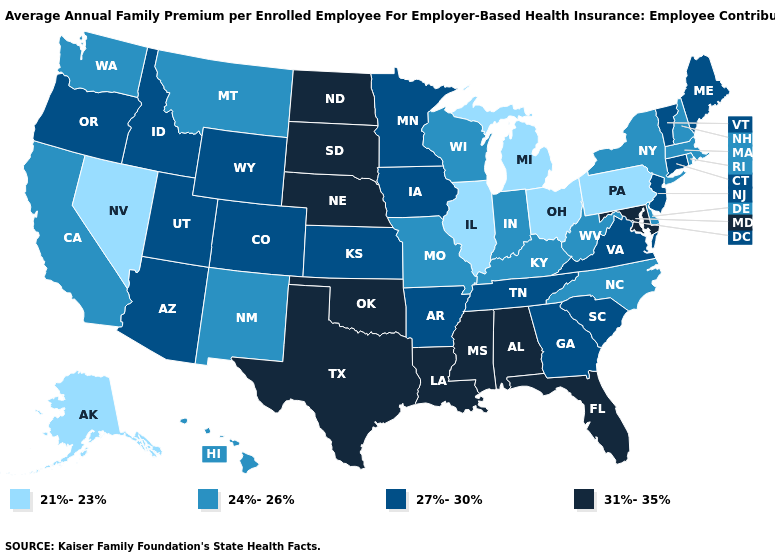Name the states that have a value in the range 27%-30%?
Keep it brief. Arizona, Arkansas, Colorado, Connecticut, Georgia, Idaho, Iowa, Kansas, Maine, Minnesota, New Jersey, Oregon, South Carolina, Tennessee, Utah, Vermont, Virginia, Wyoming. Does the map have missing data?
Write a very short answer. No. Name the states that have a value in the range 21%-23%?
Short answer required. Alaska, Illinois, Michigan, Nevada, Ohio, Pennsylvania. Name the states that have a value in the range 31%-35%?
Write a very short answer. Alabama, Florida, Louisiana, Maryland, Mississippi, Nebraska, North Dakota, Oklahoma, South Dakota, Texas. What is the lowest value in states that border North Carolina?
Short answer required. 27%-30%. What is the value of Oklahoma?
Answer briefly. 31%-35%. Does South Dakota have the highest value in the MidWest?
Answer briefly. Yes. What is the value of Maryland?
Give a very brief answer. 31%-35%. Name the states that have a value in the range 24%-26%?
Answer briefly. California, Delaware, Hawaii, Indiana, Kentucky, Massachusetts, Missouri, Montana, New Hampshire, New Mexico, New York, North Carolina, Rhode Island, Washington, West Virginia, Wisconsin. What is the highest value in the USA?
Short answer required. 31%-35%. Name the states that have a value in the range 31%-35%?
Short answer required. Alabama, Florida, Louisiana, Maryland, Mississippi, Nebraska, North Dakota, Oklahoma, South Dakota, Texas. What is the lowest value in the USA?
Keep it brief. 21%-23%. What is the value of Illinois?
Concise answer only. 21%-23%. Name the states that have a value in the range 24%-26%?
Concise answer only. California, Delaware, Hawaii, Indiana, Kentucky, Massachusetts, Missouri, Montana, New Hampshire, New Mexico, New York, North Carolina, Rhode Island, Washington, West Virginia, Wisconsin. Does the first symbol in the legend represent the smallest category?
Concise answer only. Yes. 